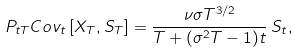<formula> <loc_0><loc_0><loc_500><loc_500>P _ { t T } C o v _ { t } \left [ X _ { T } , S _ { T } \right ] = \frac { \nu \sigma T ^ { 3 / 2 } } { T + ( \sigma ^ { 2 } T - 1 ) t } \, S _ { t } ,</formula> 